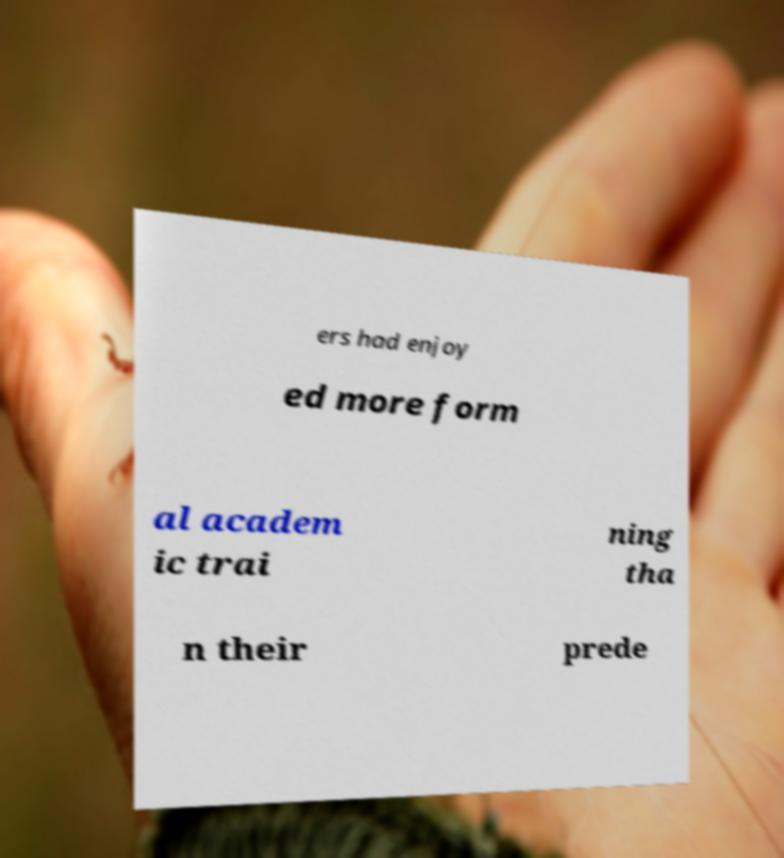Could you extract and type out the text from this image? ers had enjoy ed more form al academ ic trai ning tha n their prede 